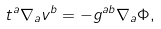<formula> <loc_0><loc_0><loc_500><loc_500>t ^ { a } \nabla _ { a } v ^ { b } = - g ^ { a b } \nabla _ { a } \Phi ,</formula> 